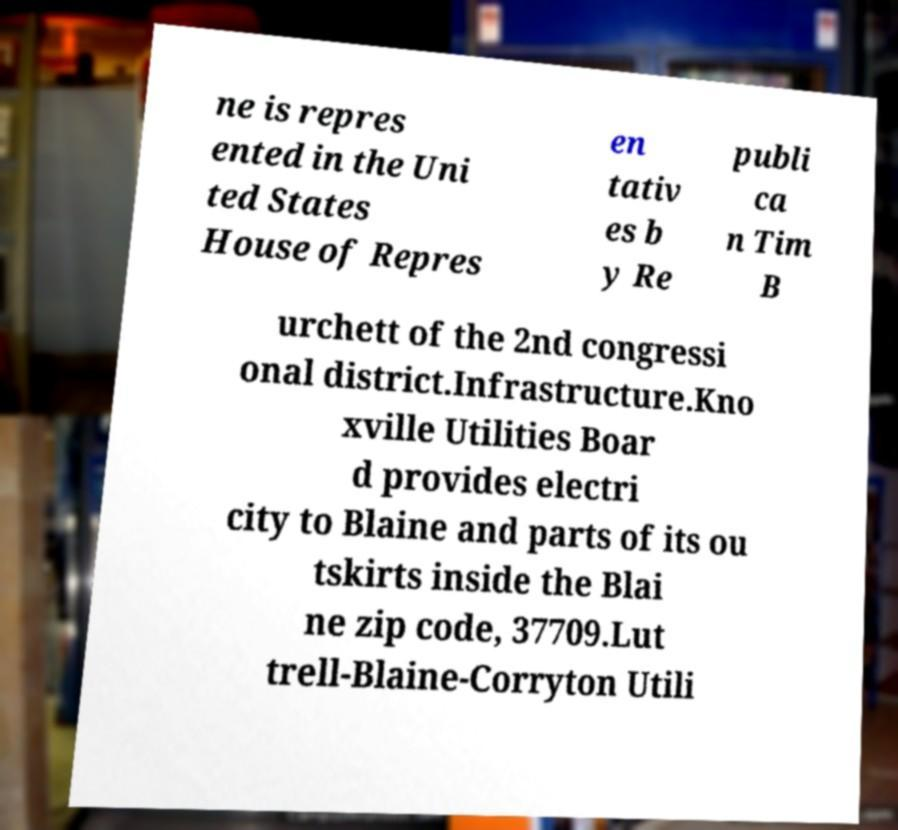Can you read and provide the text displayed in the image?This photo seems to have some interesting text. Can you extract and type it out for me? ne is repres ented in the Uni ted States House of Repres en tativ es b y Re publi ca n Tim B urchett of the 2nd congressi onal district.Infrastructure.Kno xville Utilities Boar d provides electri city to Blaine and parts of its ou tskirts inside the Blai ne zip code, 37709.Lut trell-Blaine-Corryton Utili 